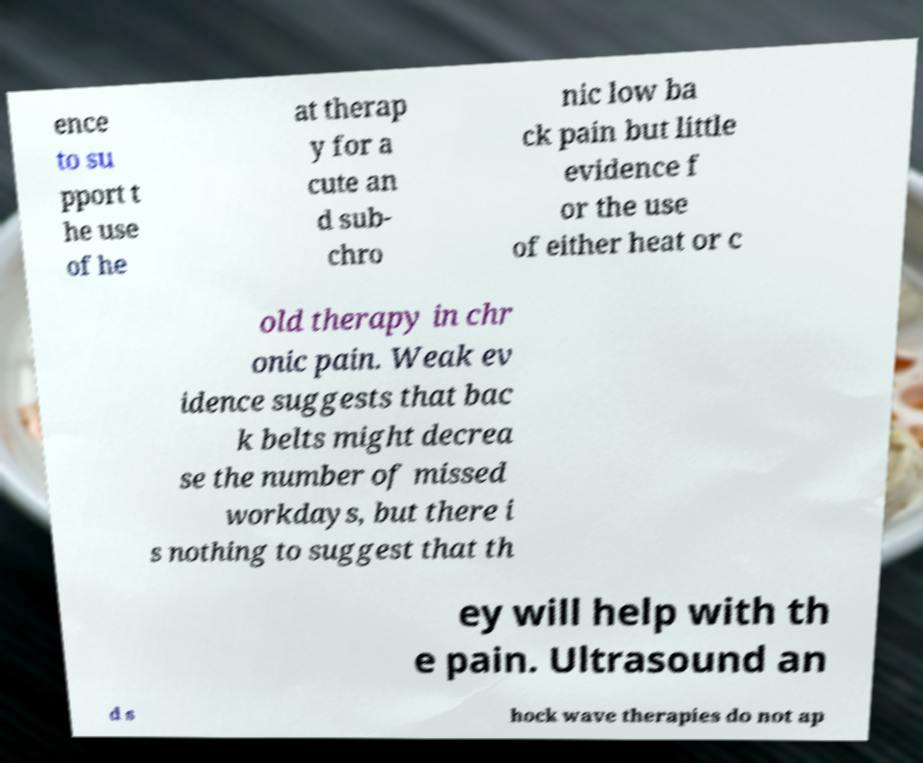Could you extract and type out the text from this image? ence to su pport t he use of he at therap y for a cute an d sub- chro nic low ba ck pain but little evidence f or the use of either heat or c old therapy in chr onic pain. Weak ev idence suggests that bac k belts might decrea se the number of missed workdays, but there i s nothing to suggest that th ey will help with th e pain. Ultrasound an d s hock wave therapies do not ap 